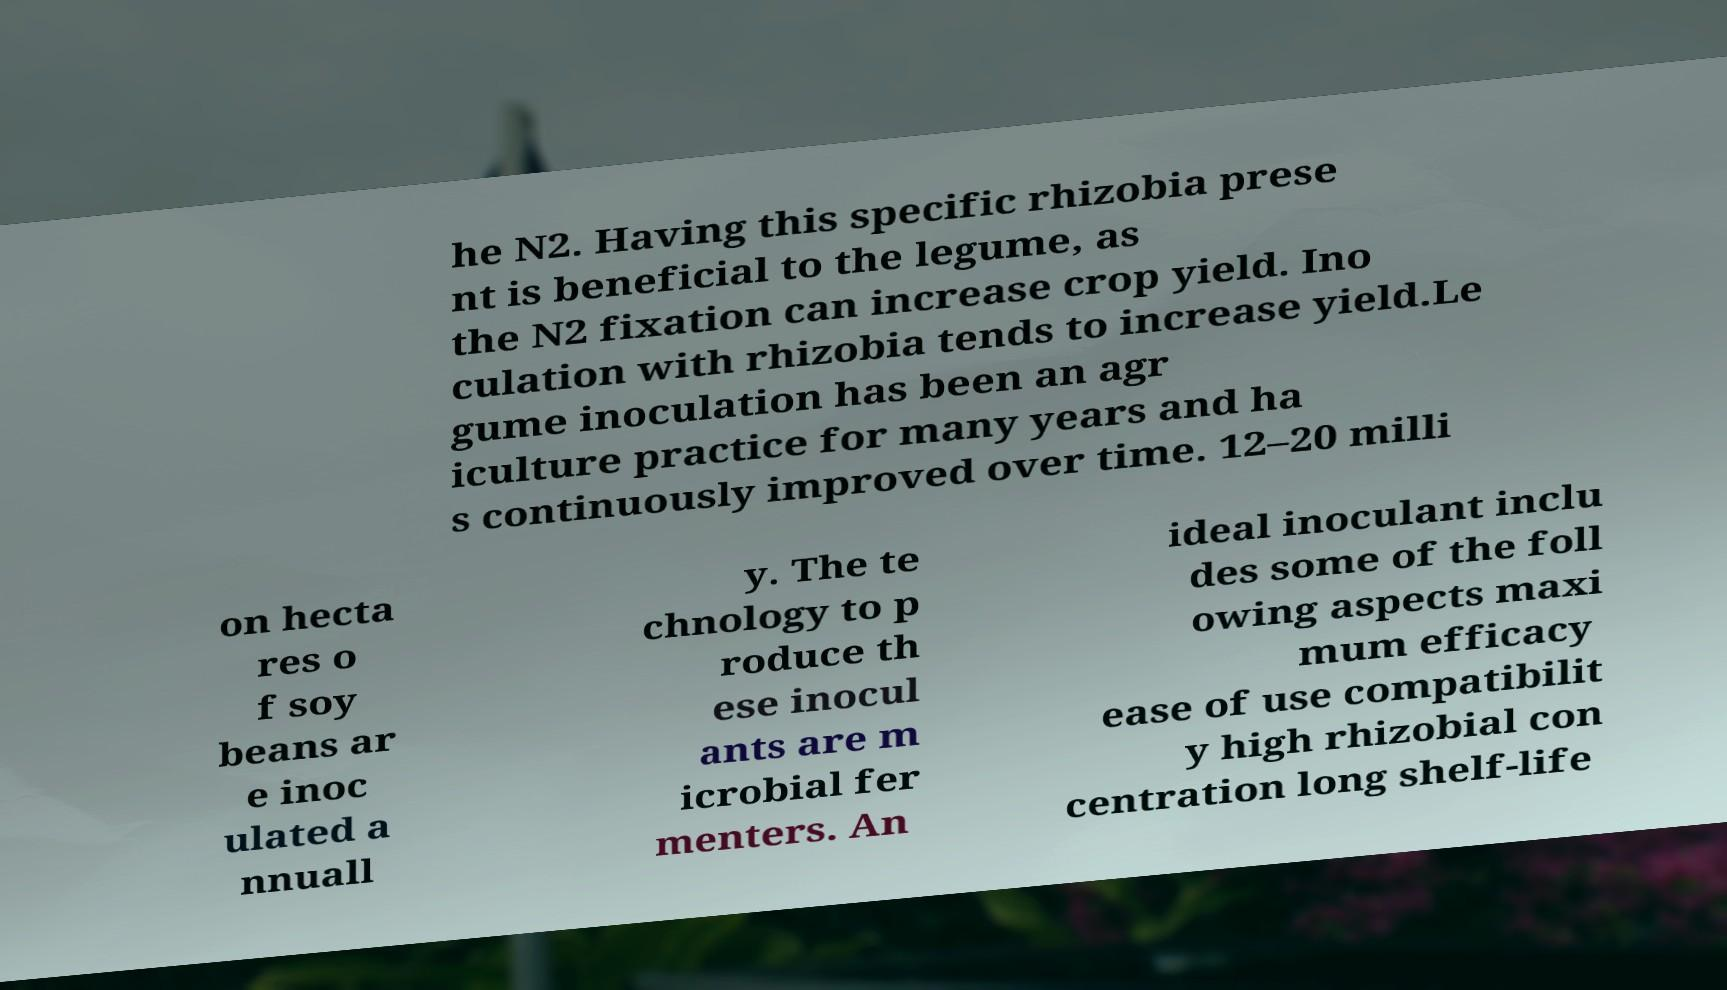Please identify and transcribe the text found in this image. he N2. Having this specific rhizobia prese nt is beneficial to the legume, as the N2 fixation can increase crop yield. Ino culation with rhizobia tends to increase yield.Le gume inoculation has been an agr iculture practice for many years and ha s continuously improved over time. 12–20 milli on hecta res o f soy beans ar e inoc ulated a nnuall y. The te chnology to p roduce th ese inocul ants are m icrobial fer menters. An ideal inoculant inclu des some of the foll owing aspects maxi mum efficacy ease of use compatibilit y high rhizobial con centration long shelf-life 